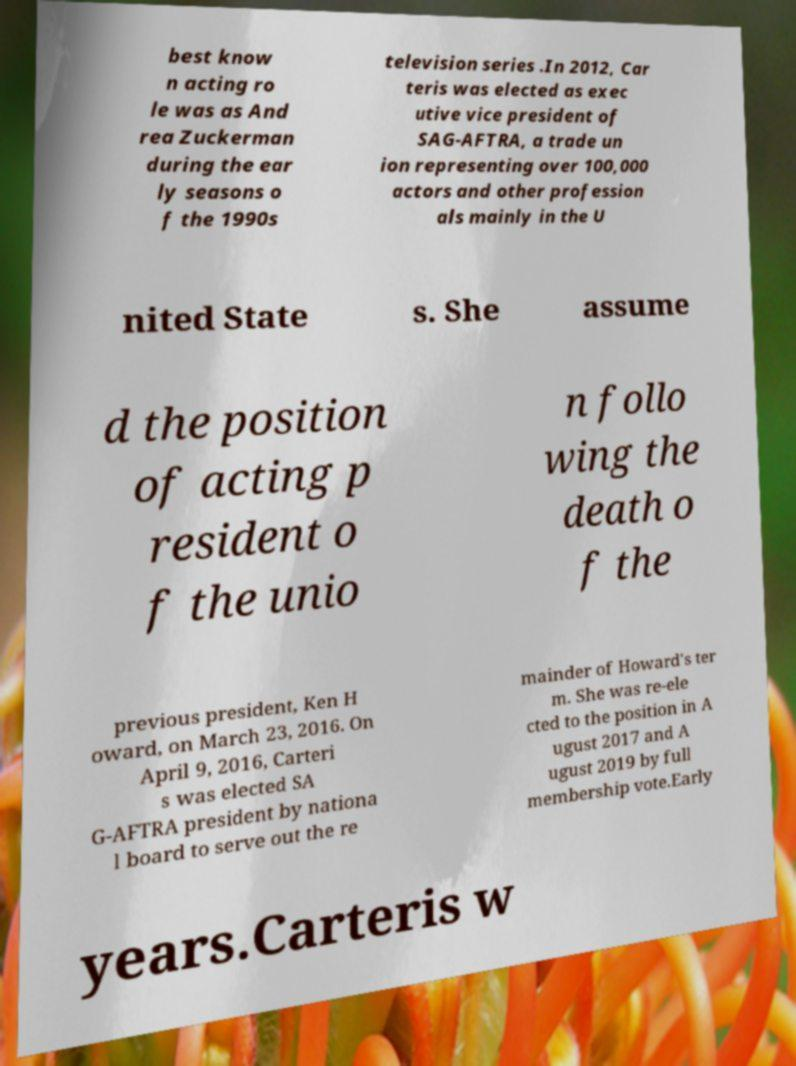Please read and relay the text visible in this image. What does it say? best know n acting ro le was as And rea Zuckerman during the ear ly seasons o f the 1990s television series .In 2012, Car teris was elected as exec utive vice president of SAG-AFTRA, a trade un ion representing over 100,000 actors and other profession als mainly in the U nited State s. She assume d the position of acting p resident o f the unio n follo wing the death o f the previous president, Ken H oward, on March 23, 2016. On April 9, 2016, Carteri s was elected SA G-AFTRA president by nationa l board to serve out the re mainder of Howard's ter m. She was re-ele cted to the position in A ugust 2017 and A ugust 2019 by full membership vote.Early years.Carteris w 